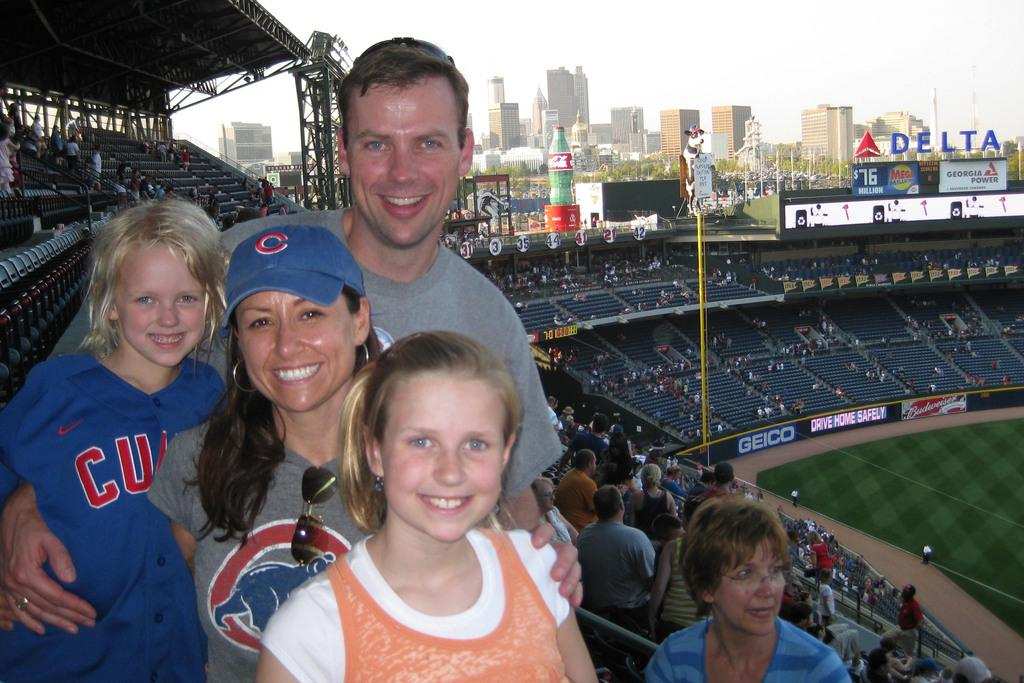What is the main subject of the image? There is a group of persons standing in the center of the image. What can be seen in the background of the image? In the background of the image, there is a stadium, grass, a crowd, chairs, name boards, a statue, a building, trees, and the sky. Can you describe the setting of the image? The image appears to be taken in an outdoor area with a stadium and various other structures and features in the background. What type of plant is being used as a wheel in the image? There is no plant being used as a wheel in the image. 